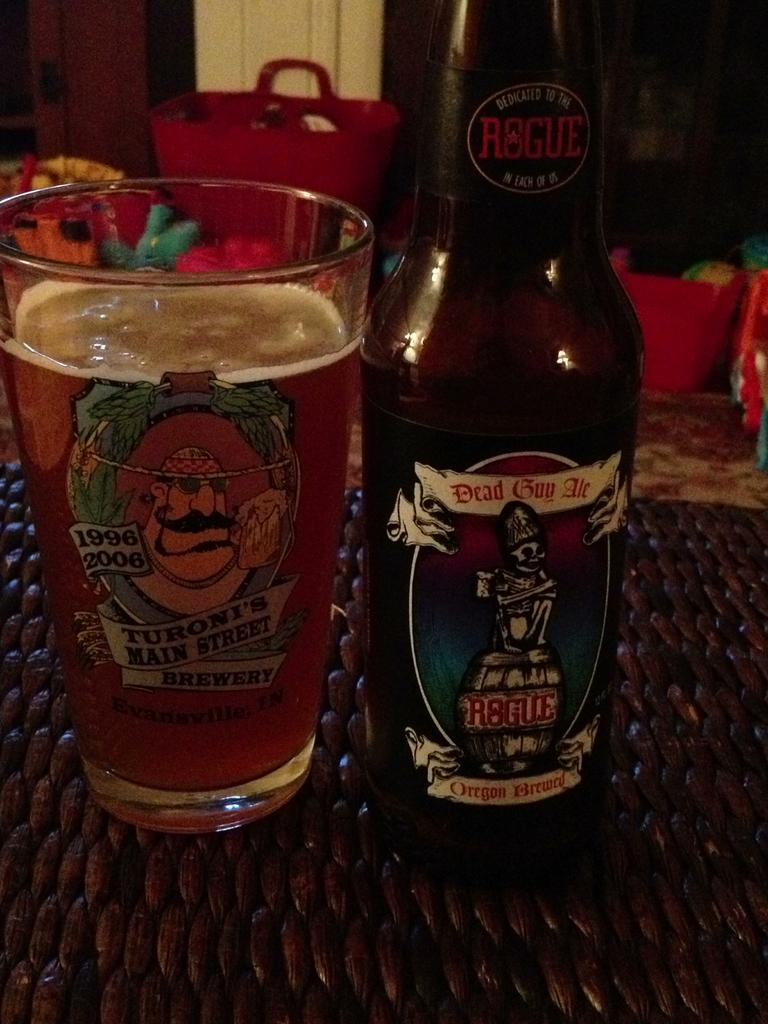<image>
Write a terse but informative summary of the picture. Beer bottle showing a man with a mustasche and the years 1996 and 2006 on it. 